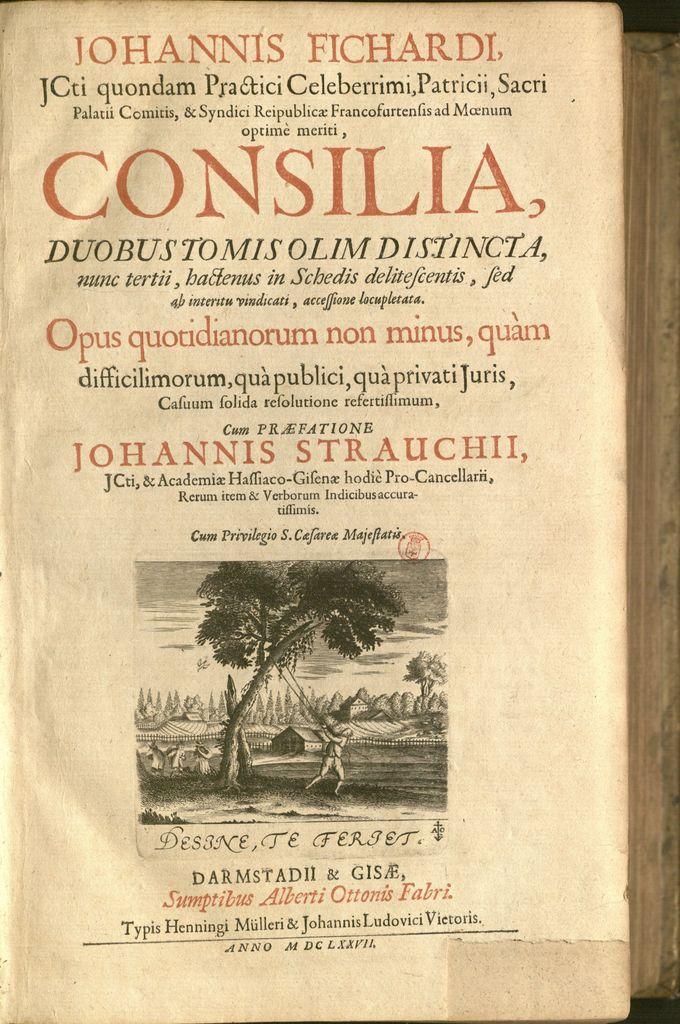Who wrote this book?
Make the answer very short. Johannis fichardi. What's the book title?
Ensure brevity in your answer.  Consilia. 